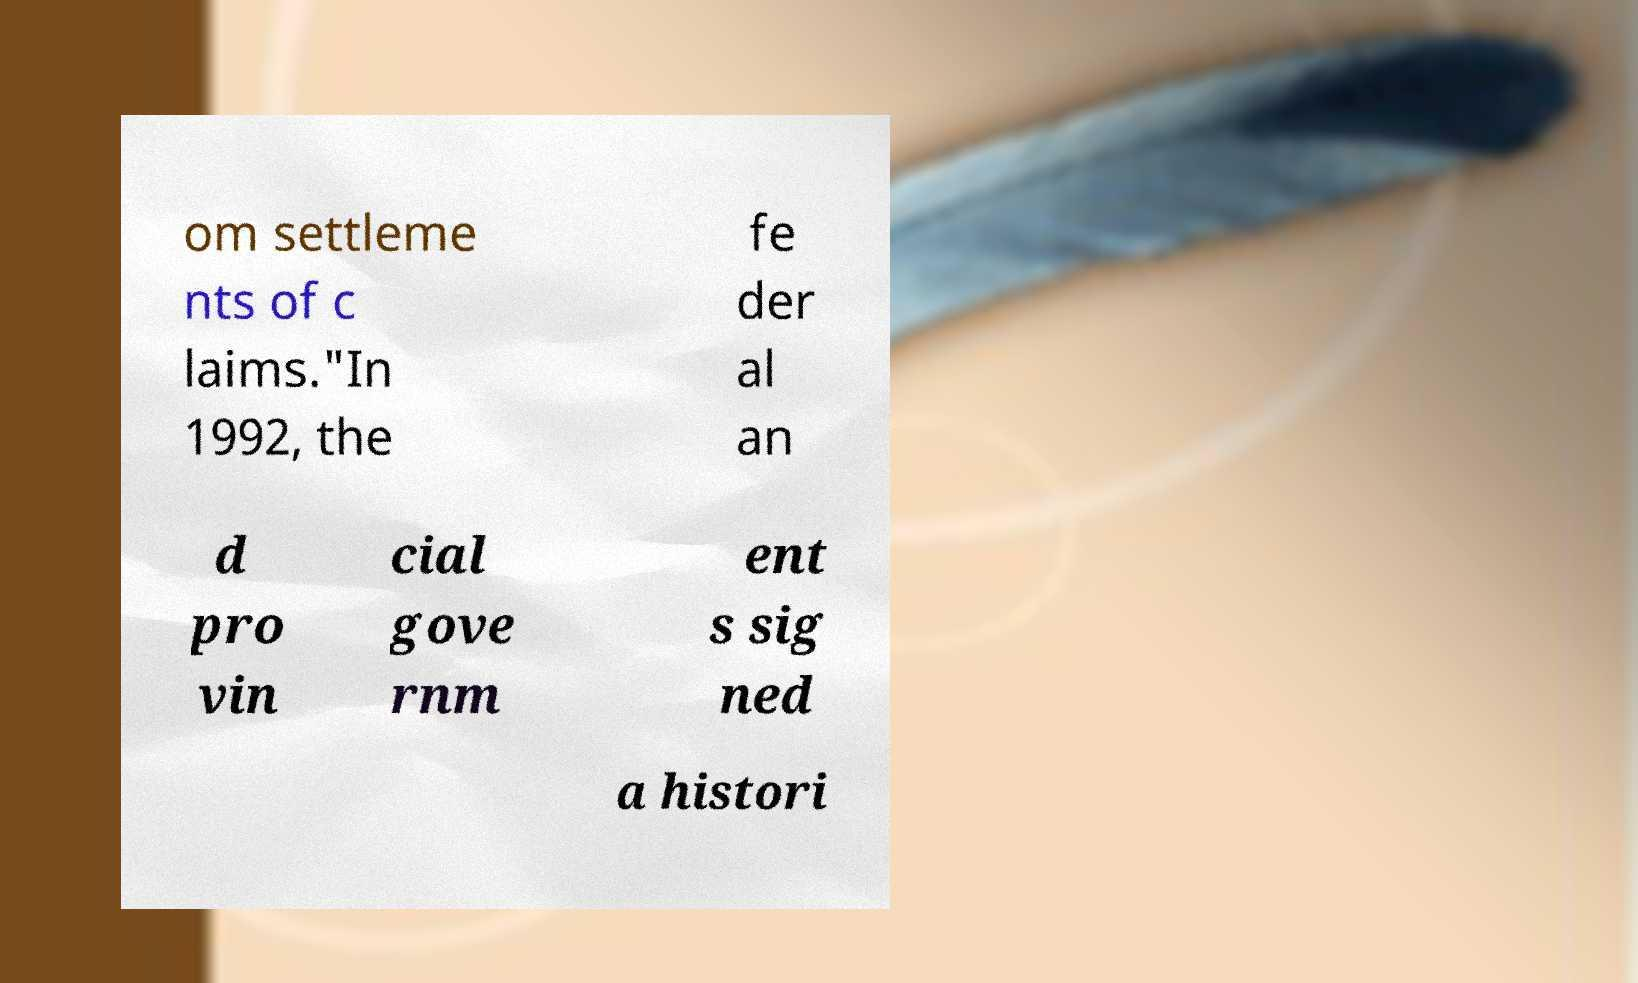Can you accurately transcribe the text from the provided image for me? om settleme nts of c laims."In 1992, the fe der al an d pro vin cial gove rnm ent s sig ned a histori 